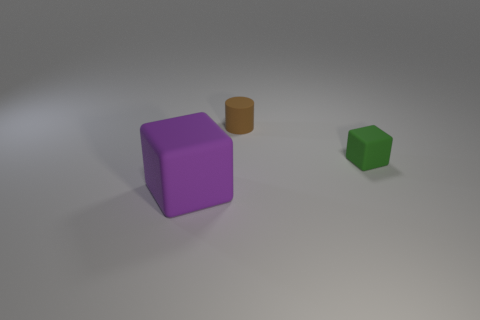Add 3 big purple objects. How many objects exist? 6 Subtract all purple blocks. How many blocks are left? 1 Subtract all cylinders. How many objects are left? 2 Add 3 big brown matte cubes. How many big brown matte cubes exist? 3 Subtract 0 purple spheres. How many objects are left? 3 Subtract all green blocks. Subtract all blue cylinders. How many blocks are left? 1 Subtract all tiny yellow cylinders. Subtract all tiny brown matte cylinders. How many objects are left? 2 Add 2 green matte things. How many green matte things are left? 3 